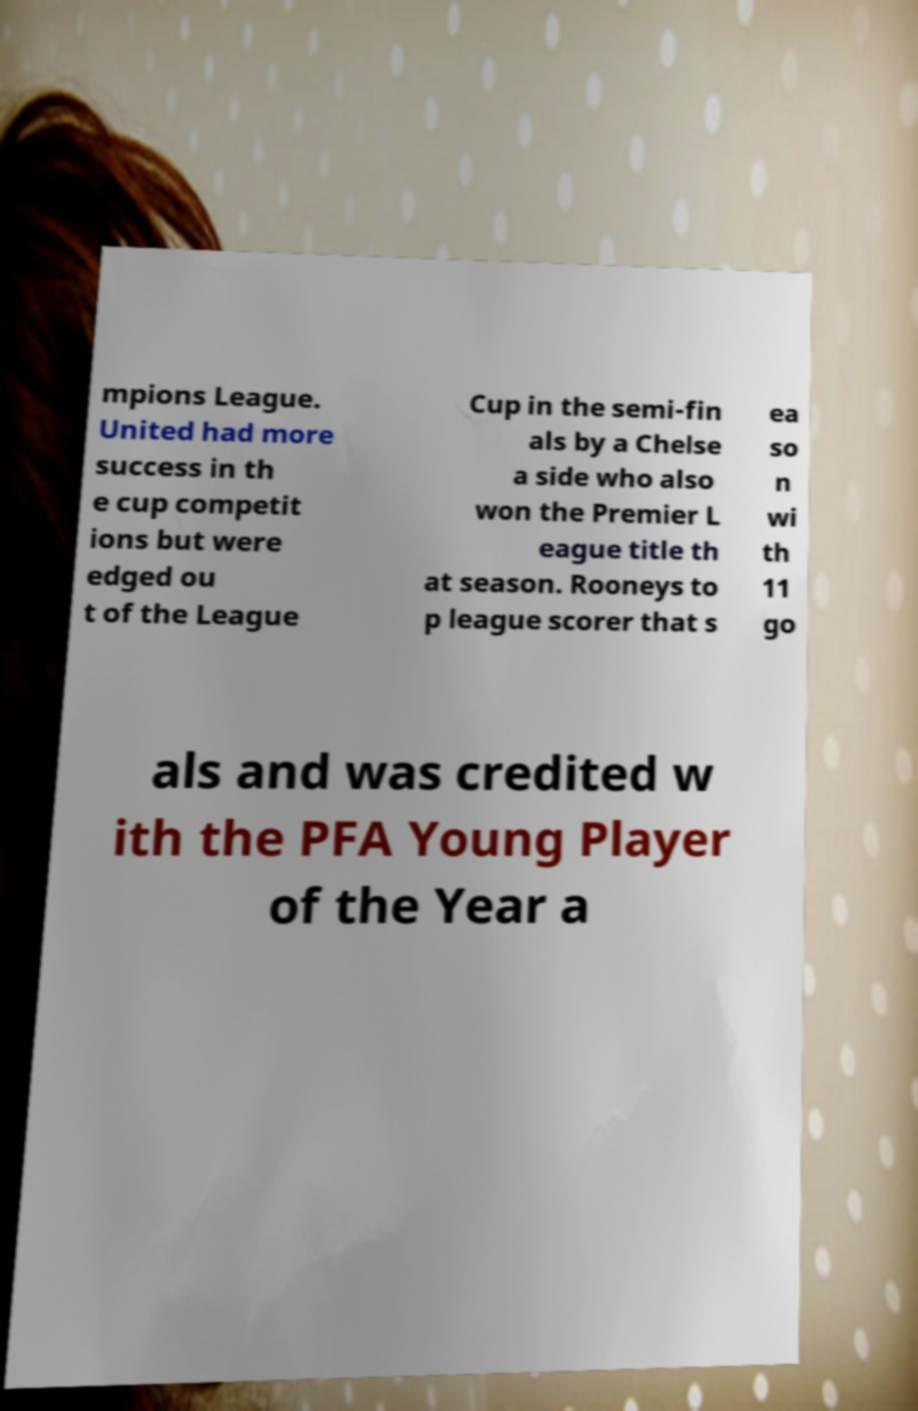For documentation purposes, I need the text within this image transcribed. Could you provide that? mpions League. United had more success in th e cup competit ions but were edged ou t of the League Cup in the semi-fin als by a Chelse a side who also won the Premier L eague title th at season. Rooneys to p league scorer that s ea so n wi th 11 go als and was credited w ith the PFA Young Player of the Year a 